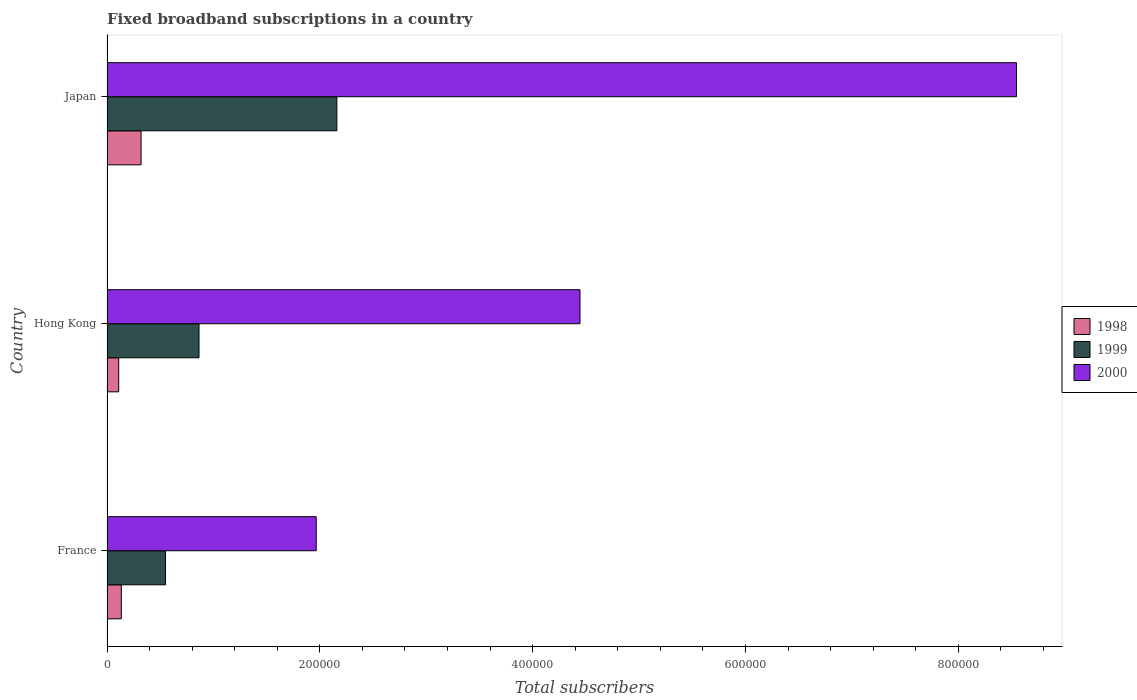How many different coloured bars are there?
Make the answer very short. 3. How many groups of bars are there?
Offer a terse response. 3. Are the number of bars per tick equal to the number of legend labels?
Offer a terse response. Yes. What is the label of the 3rd group of bars from the top?
Your response must be concise. France. What is the number of broadband subscriptions in 1999 in Japan?
Your answer should be compact. 2.16e+05. Across all countries, what is the maximum number of broadband subscriptions in 1999?
Offer a very short reply. 2.16e+05. Across all countries, what is the minimum number of broadband subscriptions in 2000?
Your answer should be compact. 1.97e+05. In which country was the number of broadband subscriptions in 2000 maximum?
Provide a short and direct response. Japan. In which country was the number of broadband subscriptions in 1998 minimum?
Keep it short and to the point. Hong Kong. What is the total number of broadband subscriptions in 1998 in the graph?
Offer a terse response. 5.65e+04. What is the difference between the number of broadband subscriptions in 2000 in Hong Kong and that in Japan?
Keep it short and to the point. -4.10e+05. What is the difference between the number of broadband subscriptions in 2000 in Hong Kong and the number of broadband subscriptions in 1998 in France?
Provide a short and direct response. 4.31e+05. What is the average number of broadband subscriptions in 1999 per country?
Keep it short and to the point. 1.19e+05. What is the difference between the number of broadband subscriptions in 1998 and number of broadband subscriptions in 1999 in Hong Kong?
Provide a succinct answer. -7.55e+04. What is the ratio of the number of broadband subscriptions in 1998 in Hong Kong to that in Japan?
Provide a succinct answer. 0.34. Is the difference between the number of broadband subscriptions in 1998 in France and Hong Kong greater than the difference between the number of broadband subscriptions in 1999 in France and Hong Kong?
Offer a very short reply. Yes. What is the difference between the highest and the second highest number of broadband subscriptions in 2000?
Make the answer very short. 4.10e+05. What is the difference between the highest and the lowest number of broadband subscriptions in 2000?
Offer a terse response. 6.58e+05. In how many countries, is the number of broadband subscriptions in 2000 greater than the average number of broadband subscriptions in 2000 taken over all countries?
Your answer should be very brief. 1. What does the 2nd bar from the top in Japan represents?
Your response must be concise. 1999. How many bars are there?
Give a very brief answer. 9. Are all the bars in the graph horizontal?
Your response must be concise. Yes. How many countries are there in the graph?
Provide a succinct answer. 3. Does the graph contain any zero values?
Offer a terse response. No. Does the graph contain grids?
Your response must be concise. No. Where does the legend appear in the graph?
Provide a succinct answer. Center right. How many legend labels are there?
Provide a short and direct response. 3. How are the legend labels stacked?
Your response must be concise. Vertical. What is the title of the graph?
Ensure brevity in your answer.  Fixed broadband subscriptions in a country. Does "1987" appear as one of the legend labels in the graph?
Ensure brevity in your answer.  No. What is the label or title of the X-axis?
Your answer should be compact. Total subscribers. What is the Total subscribers of 1998 in France?
Your answer should be compact. 1.35e+04. What is the Total subscribers in 1999 in France?
Make the answer very short. 5.50e+04. What is the Total subscribers of 2000 in France?
Provide a succinct answer. 1.97e+05. What is the Total subscribers in 1998 in Hong Kong?
Keep it short and to the point. 1.10e+04. What is the Total subscribers of 1999 in Hong Kong?
Make the answer very short. 8.65e+04. What is the Total subscribers in 2000 in Hong Kong?
Keep it short and to the point. 4.44e+05. What is the Total subscribers of 1998 in Japan?
Keep it short and to the point. 3.20e+04. What is the Total subscribers of 1999 in Japan?
Your answer should be very brief. 2.16e+05. What is the Total subscribers in 2000 in Japan?
Your answer should be compact. 8.55e+05. Across all countries, what is the maximum Total subscribers of 1998?
Keep it short and to the point. 3.20e+04. Across all countries, what is the maximum Total subscribers of 1999?
Keep it short and to the point. 2.16e+05. Across all countries, what is the maximum Total subscribers of 2000?
Offer a very short reply. 8.55e+05. Across all countries, what is the minimum Total subscribers in 1998?
Ensure brevity in your answer.  1.10e+04. Across all countries, what is the minimum Total subscribers in 1999?
Provide a succinct answer. 5.50e+04. Across all countries, what is the minimum Total subscribers in 2000?
Your response must be concise. 1.97e+05. What is the total Total subscribers in 1998 in the graph?
Offer a very short reply. 5.65e+04. What is the total Total subscribers of 1999 in the graph?
Ensure brevity in your answer.  3.57e+05. What is the total Total subscribers in 2000 in the graph?
Make the answer very short. 1.50e+06. What is the difference between the Total subscribers in 1998 in France and that in Hong Kong?
Make the answer very short. 2464. What is the difference between the Total subscribers of 1999 in France and that in Hong Kong?
Keep it short and to the point. -3.15e+04. What is the difference between the Total subscribers in 2000 in France and that in Hong Kong?
Your response must be concise. -2.48e+05. What is the difference between the Total subscribers in 1998 in France and that in Japan?
Your response must be concise. -1.85e+04. What is the difference between the Total subscribers in 1999 in France and that in Japan?
Offer a very short reply. -1.61e+05. What is the difference between the Total subscribers in 2000 in France and that in Japan?
Offer a terse response. -6.58e+05. What is the difference between the Total subscribers of 1998 in Hong Kong and that in Japan?
Keep it short and to the point. -2.10e+04. What is the difference between the Total subscribers in 1999 in Hong Kong and that in Japan?
Make the answer very short. -1.30e+05. What is the difference between the Total subscribers in 2000 in Hong Kong and that in Japan?
Offer a terse response. -4.10e+05. What is the difference between the Total subscribers of 1998 in France and the Total subscribers of 1999 in Hong Kong?
Ensure brevity in your answer.  -7.30e+04. What is the difference between the Total subscribers of 1998 in France and the Total subscribers of 2000 in Hong Kong?
Provide a succinct answer. -4.31e+05. What is the difference between the Total subscribers of 1999 in France and the Total subscribers of 2000 in Hong Kong?
Make the answer very short. -3.89e+05. What is the difference between the Total subscribers of 1998 in France and the Total subscribers of 1999 in Japan?
Your answer should be compact. -2.03e+05. What is the difference between the Total subscribers in 1998 in France and the Total subscribers in 2000 in Japan?
Offer a terse response. -8.41e+05. What is the difference between the Total subscribers of 1999 in France and the Total subscribers of 2000 in Japan?
Ensure brevity in your answer.  -8.00e+05. What is the difference between the Total subscribers of 1998 in Hong Kong and the Total subscribers of 1999 in Japan?
Offer a very short reply. -2.05e+05. What is the difference between the Total subscribers in 1998 in Hong Kong and the Total subscribers in 2000 in Japan?
Your answer should be compact. -8.44e+05. What is the difference between the Total subscribers of 1999 in Hong Kong and the Total subscribers of 2000 in Japan?
Provide a succinct answer. -7.68e+05. What is the average Total subscribers of 1998 per country?
Offer a terse response. 1.88e+04. What is the average Total subscribers of 1999 per country?
Your answer should be compact. 1.19e+05. What is the average Total subscribers in 2000 per country?
Ensure brevity in your answer.  4.99e+05. What is the difference between the Total subscribers in 1998 and Total subscribers in 1999 in France?
Provide a short and direct response. -4.15e+04. What is the difference between the Total subscribers in 1998 and Total subscribers in 2000 in France?
Offer a very short reply. -1.83e+05. What is the difference between the Total subscribers in 1999 and Total subscribers in 2000 in France?
Ensure brevity in your answer.  -1.42e+05. What is the difference between the Total subscribers of 1998 and Total subscribers of 1999 in Hong Kong?
Your answer should be very brief. -7.55e+04. What is the difference between the Total subscribers of 1998 and Total subscribers of 2000 in Hong Kong?
Provide a short and direct response. -4.33e+05. What is the difference between the Total subscribers in 1999 and Total subscribers in 2000 in Hong Kong?
Provide a short and direct response. -3.58e+05. What is the difference between the Total subscribers of 1998 and Total subscribers of 1999 in Japan?
Ensure brevity in your answer.  -1.84e+05. What is the difference between the Total subscribers of 1998 and Total subscribers of 2000 in Japan?
Your answer should be compact. -8.23e+05. What is the difference between the Total subscribers of 1999 and Total subscribers of 2000 in Japan?
Give a very brief answer. -6.39e+05. What is the ratio of the Total subscribers of 1998 in France to that in Hong Kong?
Keep it short and to the point. 1.22. What is the ratio of the Total subscribers of 1999 in France to that in Hong Kong?
Your response must be concise. 0.64. What is the ratio of the Total subscribers of 2000 in France to that in Hong Kong?
Offer a terse response. 0.44. What is the ratio of the Total subscribers in 1998 in France to that in Japan?
Offer a very short reply. 0.42. What is the ratio of the Total subscribers of 1999 in France to that in Japan?
Your response must be concise. 0.25. What is the ratio of the Total subscribers of 2000 in France to that in Japan?
Keep it short and to the point. 0.23. What is the ratio of the Total subscribers in 1998 in Hong Kong to that in Japan?
Make the answer very short. 0.34. What is the ratio of the Total subscribers of 1999 in Hong Kong to that in Japan?
Your response must be concise. 0.4. What is the ratio of the Total subscribers of 2000 in Hong Kong to that in Japan?
Provide a succinct answer. 0.52. What is the difference between the highest and the second highest Total subscribers in 1998?
Offer a terse response. 1.85e+04. What is the difference between the highest and the second highest Total subscribers of 1999?
Your answer should be very brief. 1.30e+05. What is the difference between the highest and the second highest Total subscribers of 2000?
Ensure brevity in your answer.  4.10e+05. What is the difference between the highest and the lowest Total subscribers in 1998?
Offer a very short reply. 2.10e+04. What is the difference between the highest and the lowest Total subscribers of 1999?
Provide a short and direct response. 1.61e+05. What is the difference between the highest and the lowest Total subscribers of 2000?
Provide a succinct answer. 6.58e+05. 